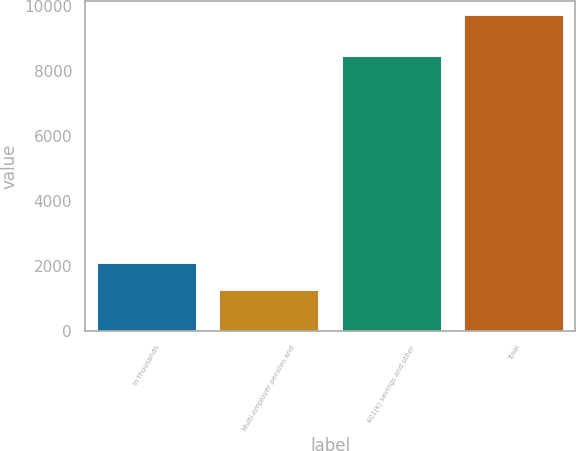<chart> <loc_0><loc_0><loc_500><loc_500><bar_chart><fcel>In thousands<fcel>Multi-employer pension and<fcel>401(k) savings and other<fcel>Total<nl><fcel>2077.3<fcel>1233<fcel>8443<fcel>9676<nl></chart> 